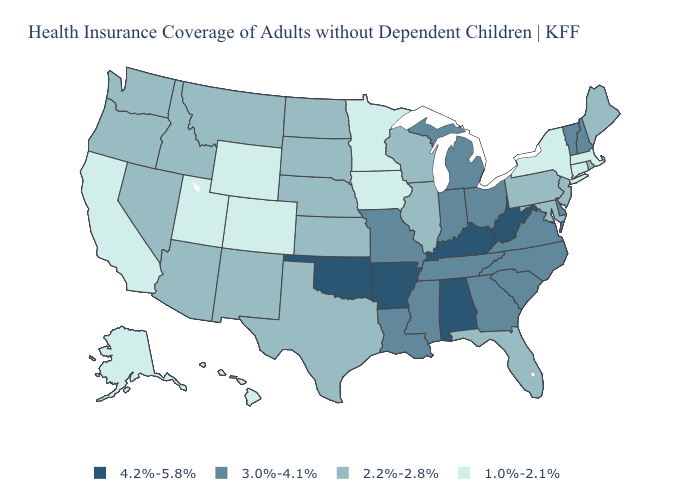Which states have the lowest value in the Northeast?
Keep it brief. Connecticut, Massachusetts, New York. Name the states that have a value in the range 2.2%-2.8%?
Short answer required. Arizona, Florida, Idaho, Illinois, Kansas, Maine, Maryland, Montana, Nebraska, Nevada, New Jersey, New Mexico, North Dakota, Oregon, Pennsylvania, Rhode Island, South Dakota, Texas, Washington, Wisconsin. Does Minnesota have the same value as Colorado?
Quick response, please. Yes. Among the states that border Mississippi , which have the lowest value?
Write a very short answer. Louisiana, Tennessee. What is the highest value in the USA?
Be succinct. 4.2%-5.8%. What is the lowest value in the USA?
Answer briefly. 1.0%-2.1%. What is the lowest value in the USA?
Give a very brief answer. 1.0%-2.1%. What is the value of California?
Keep it brief. 1.0%-2.1%. Name the states that have a value in the range 3.0%-4.1%?
Answer briefly. Delaware, Georgia, Indiana, Louisiana, Michigan, Mississippi, Missouri, New Hampshire, North Carolina, Ohio, South Carolina, Tennessee, Vermont, Virginia. Does the first symbol in the legend represent the smallest category?
Short answer required. No. Name the states that have a value in the range 2.2%-2.8%?
Concise answer only. Arizona, Florida, Idaho, Illinois, Kansas, Maine, Maryland, Montana, Nebraska, Nevada, New Jersey, New Mexico, North Dakota, Oregon, Pennsylvania, Rhode Island, South Dakota, Texas, Washington, Wisconsin. What is the value of Nebraska?
Short answer required. 2.2%-2.8%. Name the states that have a value in the range 1.0%-2.1%?
Give a very brief answer. Alaska, California, Colorado, Connecticut, Hawaii, Iowa, Massachusetts, Minnesota, New York, Utah, Wyoming. What is the highest value in the Northeast ?
Concise answer only. 3.0%-4.1%. 